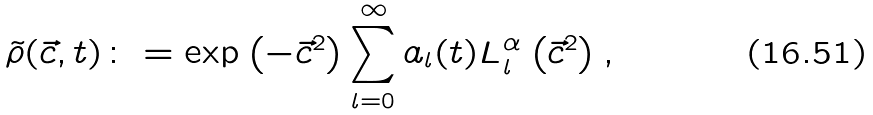<formula> <loc_0><loc_0><loc_500><loc_500>\tilde { \rho } ( \vec { c } , t ) \colon = \exp \left ( - \vec { c } ^ { 2 } \right ) \sum _ { l = 0 } ^ { \infty } a _ { l } ( t ) L _ { l } ^ { \alpha } \left ( \vec { c } ^ { 2 } \right ) ,</formula> 